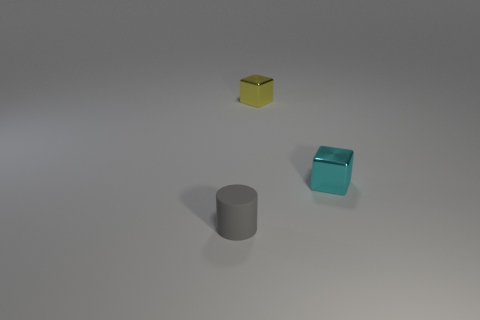Is there anything else that is the same material as the gray cylinder?
Ensure brevity in your answer.  No. Is the material of the gray cylinder the same as the object right of the yellow cube?
Provide a short and direct response. No. Is the number of tiny blocks in front of the yellow object less than the number of metal things right of the tiny rubber cylinder?
Provide a short and direct response. Yes. What is the material of the cube in front of the small yellow thing?
Offer a terse response. Metal. There is a small thing that is both behind the tiny gray cylinder and in front of the yellow thing; what is its color?
Ensure brevity in your answer.  Cyan. There is a object in front of the small cyan metallic thing; what color is it?
Offer a terse response. Gray. Is there a yellow shiny object of the same size as the gray rubber cylinder?
Make the answer very short. Yes. There is another yellow thing that is the same size as the matte thing; what is its material?
Ensure brevity in your answer.  Metal. What number of objects are small things that are to the right of the gray matte cylinder or metal objects that are to the right of the tiny yellow metallic cube?
Your answer should be compact. 2. Is there a gray matte object that has the same shape as the tiny yellow object?
Your answer should be compact. No. 